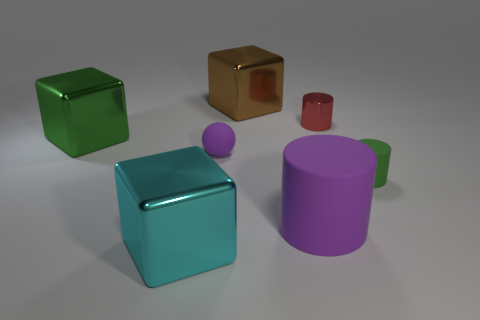How many other things are there of the same shape as the tiny purple object?
Offer a terse response. 0. Are there any other things that have the same material as the big brown object?
Make the answer very short. Yes. Do the green thing left of the small green matte thing and the brown thing have the same shape?
Offer a terse response. Yes. What is the color of the tiny thing that is behind the big green shiny object?
Make the answer very short. Red. What is the shape of the big cyan thing that is the same material as the small red object?
Give a very brief answer. Cube. Are there any other things that are the same color as the big cylinder?
Your response must be concise. Yes. Are there more cylinders to the left of the tiny red metal cylinder than purple things that are left of the green metallic object?
Keep it short and to the point. Yes. What number of red shiny cylinders are the same size as the cyan metal thing?
Provide a succinct answer. 0. Is the number of cubes to the right of the red metal cylinder less than the number of cyan objects that are behind the green metallic object?
Your response must be concise. No. Is there another object of the same shape as the cyan object?
Ensure brevity in your answer.  Yes. 